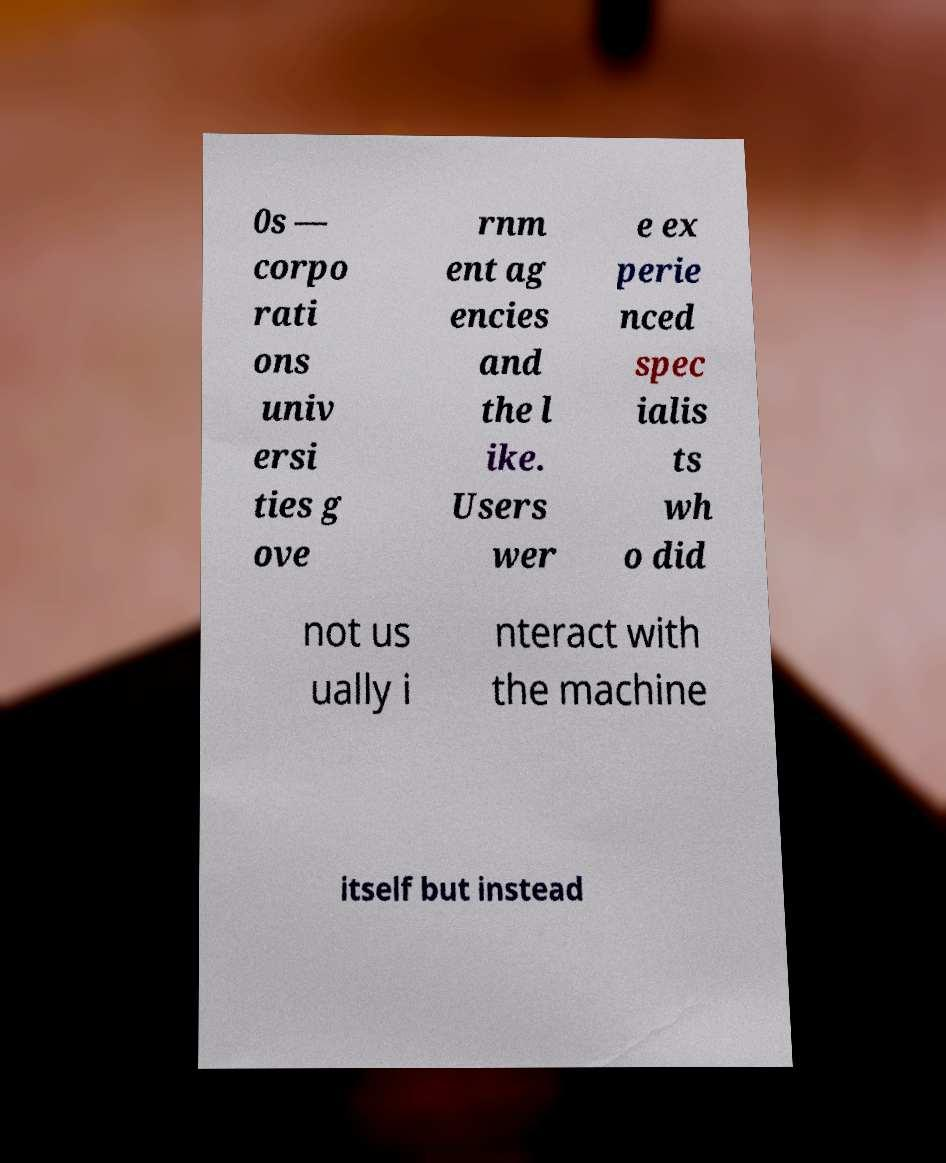What messages or text are displayed in this image? I need them in a readable, typed format. 0s — corpo rati ons univ ersi ties g ove rnm ent ag encies and the l ike. Users wer e ex perie nced spec ialis ts wh o did not us ually i nteract with the machine itself but instead 